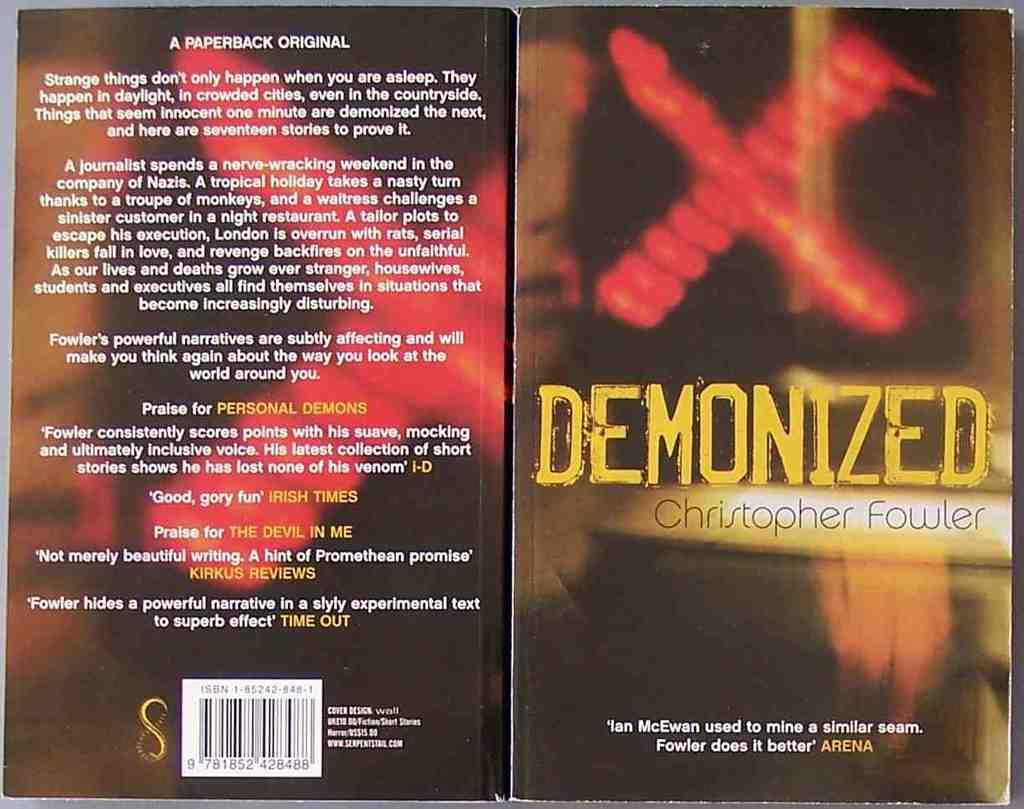<image>
Render a clear and concise summary of the photo. the front and back covers of the book demonized written by cristopher fowler. 